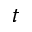Convert formula to latex. <formula><loc_0><loc_0><loc_500><loc_500>t</formula> 